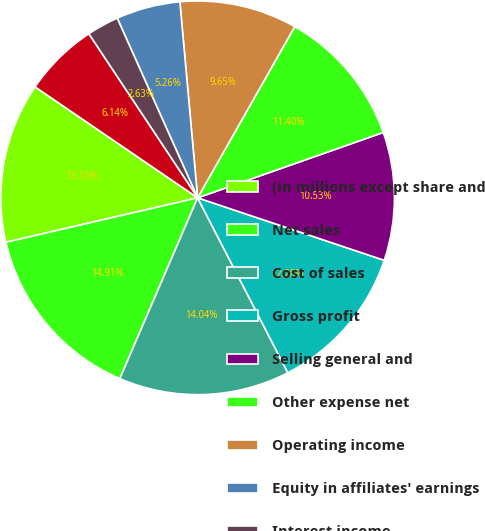Convert chart to OTSL. <chart><loc_0><loc_0><loc_500><loc_500><pie_chart><fcel>(in millions except share and<fcel>Net sales<fcel>Cost of sales<fcel>Gross profit<fcel>Selling general and<fcel>Other expense net<fcel>Operating income<fcel>Equity in affiliates' earnings<fcel>Interest income<fcel>Interest expense and finance<nl><fcel>13.16%<fcel>14.91%<fcel>14.04%<fcel>12.28%<fcel>10.53%<fcel>11.4%<fcel>9.65%<fcel>5.26%<fcel>2.63%<fcel>6.14%<nl></chart> 